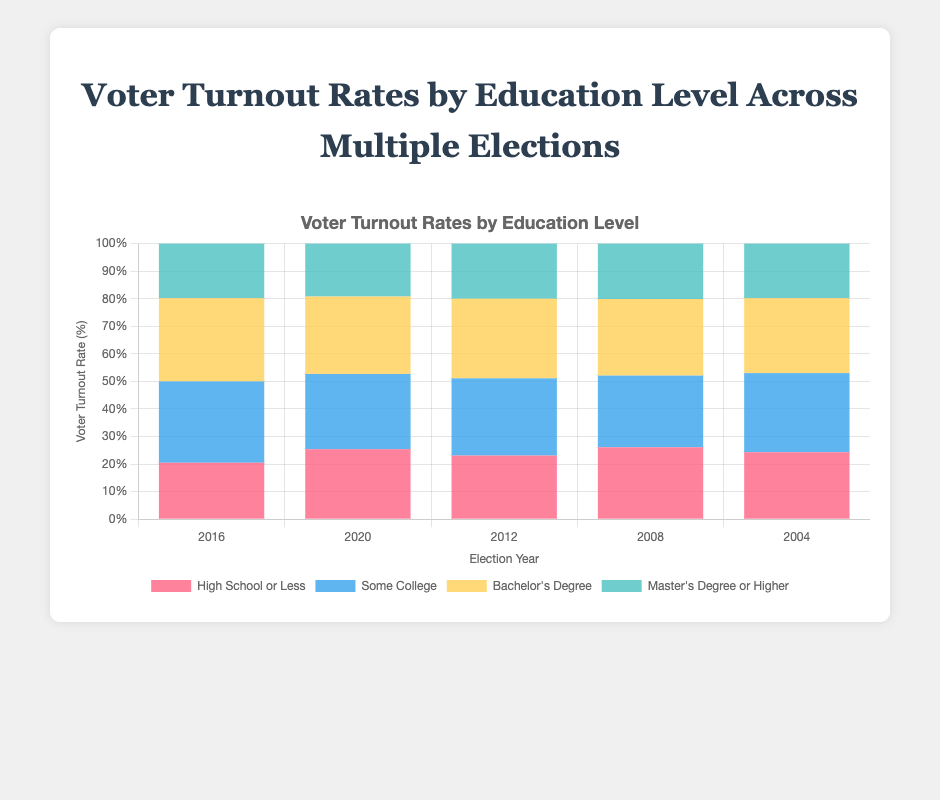What was the voter turnout rate for those with a Bachelor's Degree in the 2016 election? By looking at the bar corresponding to the Bachelor's Degree level for the year 2016, the height indicates the turnout rate.
Answer: 30.2% What is the difference in voter turnout rates for 'High School or Less' between 2012 and 2020? Check the bar heights for 'High School or Less' in the years 2012 and 2020 and subtract the former from the latter (25.4% - 23.1%).
Answer: 2.3% How has the voter turnout rate for people with 'Some College' level education changed from 2004 to 2020? Compare the bar heights for 'Some College' in 2004 (28.7%) and 2020 (27.3%). The difference is 27.3% - 28.7%.
Answer: -1.4% Which education level had the highest voter turnout rate in 2008? Look at the bars for the year 2008 and identify which one is the tallest. 'High School or Less' (26.1%), 'Some College' (26.0%), 'Bachelor's Degree' (27.8%), or 'Master's Degree or Higher' (20.1%).
Answer: Bachelor's Degree Across all the years depicted, which education level generally has the lowest voter turnout rate? Compare the overall heights of the bars for each education level across all years and identify which level's bars are generally the shortest.
Answer: Master's Degree or Higher 